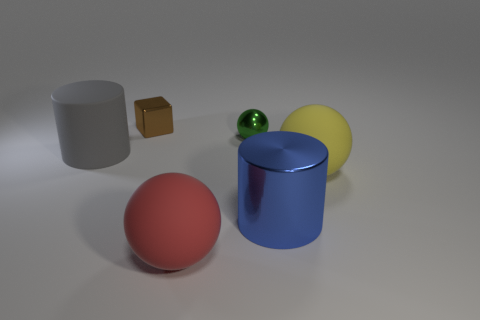Are there an equal number of blue things that are behind the tiny metal sphere and tiny cyan metallic blocks?
Make the answer very short. Yes. There is a small green object that is the same shape as the red thing; what is its material?
Your response must be concise. Metal. There is a big matte thing on the right side of the large ball that is left of the blue metal cylinder; what shape is it?
Offer a terse response. Sphere. Are the cylinder that is behind the yellow rubber thing and the big red object made of the same material?
Your answer should be compact. Yes. Are there the same number of shiny things in front of the tiny metal block and blue cylinders in front of the blue cylinder?
Offer a very short reply. No. How many large cylinders are left of the large cylinder right of the large red object?
Give a very brief answer. 1. What material is the yellow thing that is the same size as the red rubber thing?
Your answer should be compact. Rubber. The rubber thing that is right of the rubber ball that is in front of the large shiny cylinder that is in front of the metal ball is what shape?
Ensure brevity in your answer.  Sphere. What is the shape of the green metal object that is the same size as the brown metallic thing?
Offer a very short reply. Sphere. What number of large red objects are behind the ball that is behind the large cylinder left of the large red sphere?
Give a very brief answer. 0. 